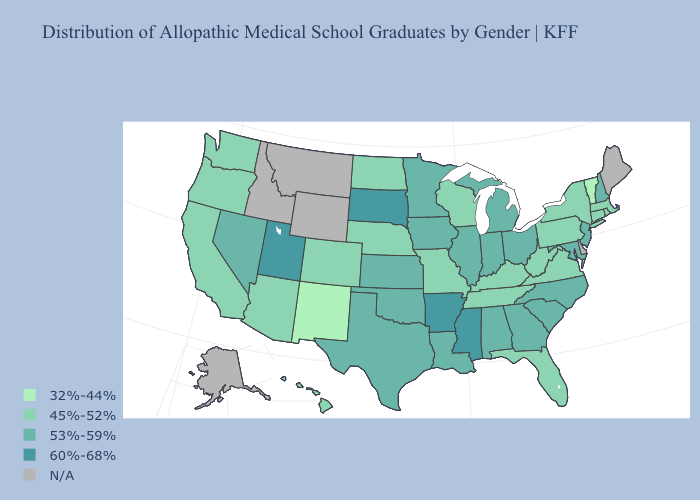Does the map have missing data?
Quick response, please. Yes. Among the states that border Alabama , does Georgia have the lowest value?
Quick response, please. No. Which states have the lowest value in the South?
Keep it brief. Florida, Kentucky, Tennessee, Virginia, West Virginia. What is the value of Massachusetts?
Keep it brief. 45%-52%. Name the states that have a value in the range N/A?
Keep it brief. Alaska, Delaware, Idaho, Maine, Montana, Wyoming. What is the value of South Carolina?
Keep it brief. 53%-59%. Does New Mexico have the lowest value in the USA?
Short answer required. Yes. Name the states that have a value in the range 53%-59%?
Keep it brief. Alabama, Georgia, Illinois, Indiana, Iowa, Kansas, Louisiana, Maryland, Michigan, Minnesota, Nevada, New Hampshire, New Jersey, North Carolina, Ohio, Oklahoma, South Carolina, Texas. How many symbols are there in the legend?
Write a very short answer. 5. Does Oregon have the highest value in the West?
Keep it brief. No. Name the states that have a value in the range 60%-68%?
Be succinct. Arkansas, Mississippi, South Dakota, Utah. Name the states that have a value in the range 45%-52%?
Give a very brief answer. Arizona, California, Colorado, Connecticut, Florida, Hawaii, Kentucky, Massachusetts, Missouri, Nebraska, New York, North Dakota, Oregon, Pennsylvania, Rhode Island, Tennessee, Virginia, Washington, West Virginia, Wisconsin. What is the value of Pennsylvania?
Write a very short answer. 45%-52%. 